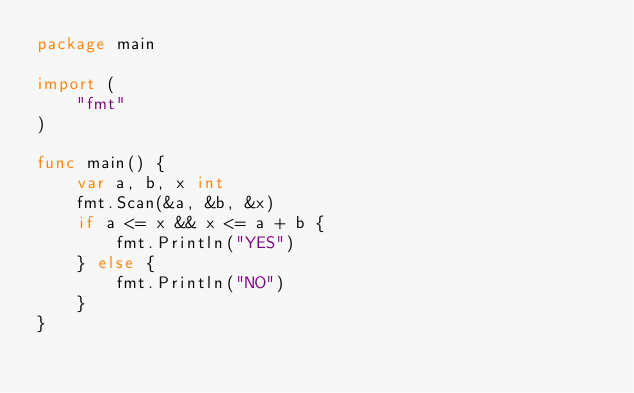<code> <loc_0><loc_0><loc_500><loc_500><_Go_>package main

import (
	"fmt"
)

func main() {
	var a, b, x int
	fmt.Scan(&a, &b, &x)
	if a <= x && x <= a + b {
		fmt.Println("YES")
	} else {
		fmt.Println("NO")
	}
}
</code> 